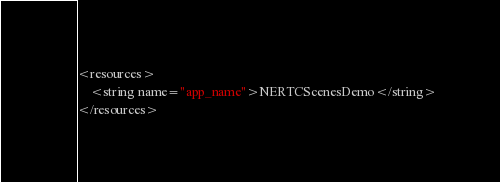<code> <loc_0><loc_0><loc_500><loc_500><_XML_><resources>
    <string name="app_name">NERTCScenesDemo</string>
</resources></code> 